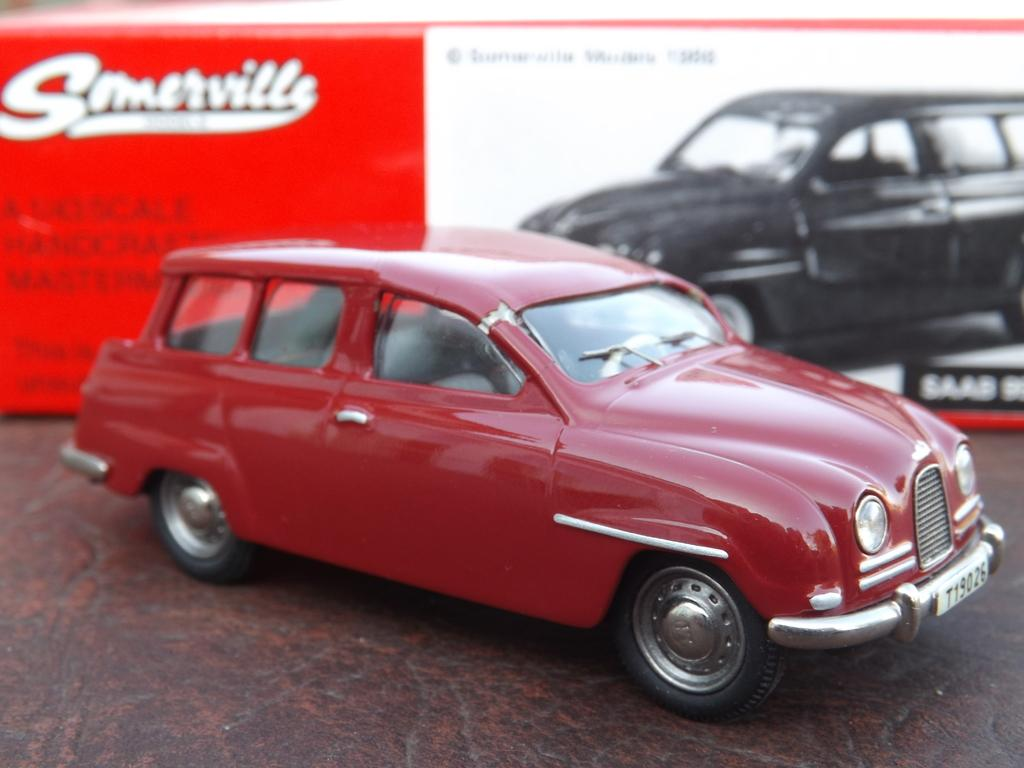What color is the floor in the image? The floor in the image is brown. How many cars are visible in the image? There are two cars in the image, one red and one black. Can you describe the board in the image? The board in the image has a red and white color scheme and some text. How many geese are standing near the red car in the image? There are no geese present in the image. What is the mass of the board in the image? The mass of the board cannot be determined from the image alone. 